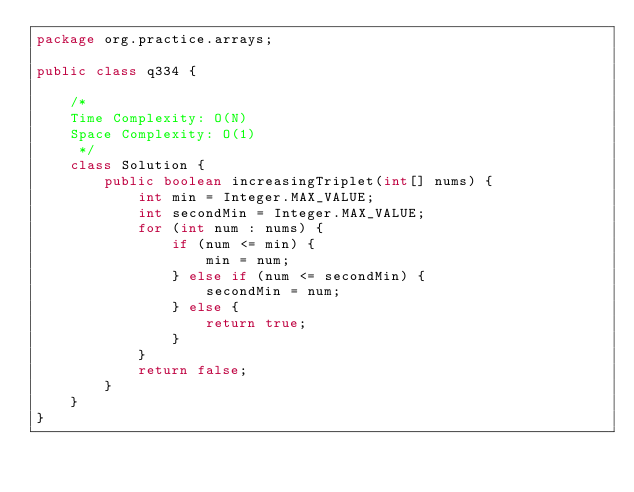Convert code to text. <code><loc_0><loc_0><loc_500><loc_500><_Java_>package org.practice.arrays;

public class q334 {

    /*
    Time Complexity: O(N)
    Space Complexity: O(1)
     */
    class Solution {
        public boolean increasingTriplet(int[] nums) {
            int min = Integer.MAX_VALUE;
            int secondMin = Integer.MAX_VALUE;
            for (int num : nums) {
                if (num <= min) {
                    min = num;
                } else if (num <= secondMin) {
                    secondMin = num;
                } else {
                    return true;
                }
            }
            return false;
        }
    }
}
</code> 